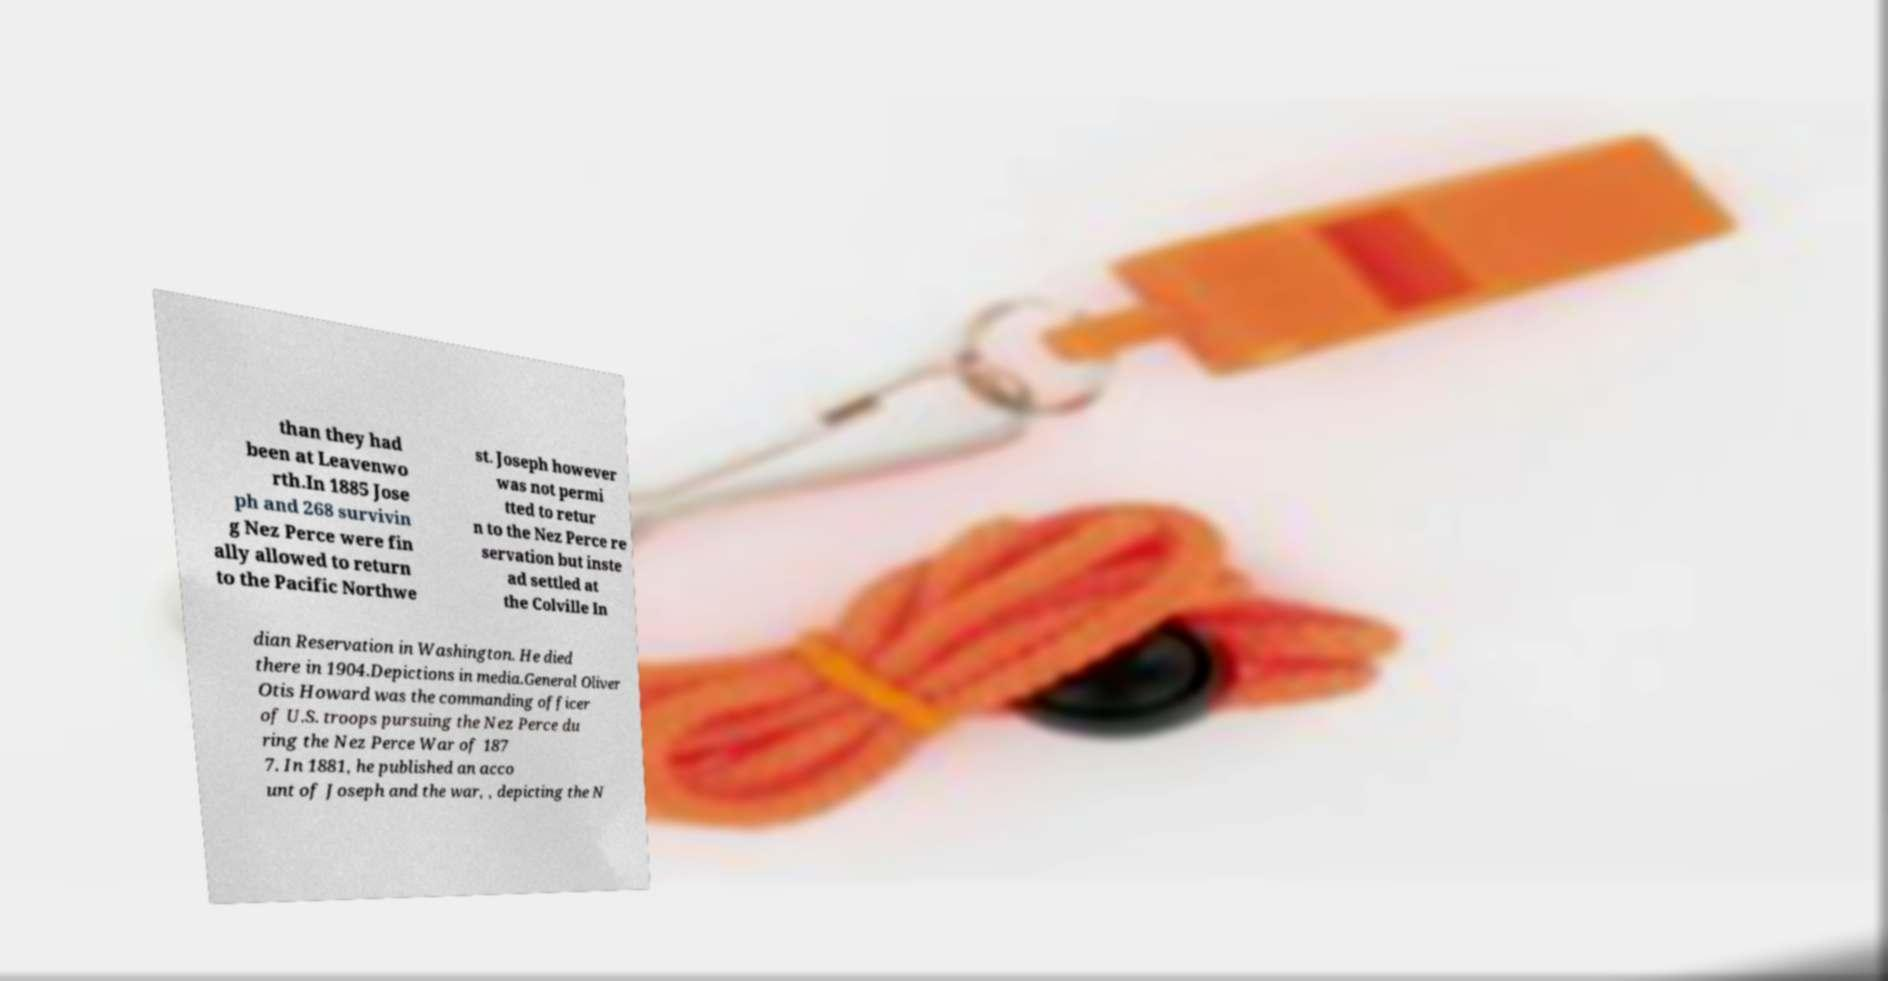Can you read and provide the text displayed in the image?This photo seems to have some interesting text. Can you extract and type it out for me? than they had been at Leavenwo rth.In 1885 Jose ph and 268 survivin g Nez Perce were fin ally allowed to return to the Pacific Northwe st. Joseph however was not permi tted to retur n to the Nez Perce re servation but inste ad settled at the Colville In dian Reservation in Washington. He died there in 1904.Depictions in media.General Oliver Otis Howard was the commanding officer of U.S. troops pursuing the Nez Perce du ring the Nez Perce War of 187 7. In 1881, he published an acco unt of Joseph and the war, , depicting the N 